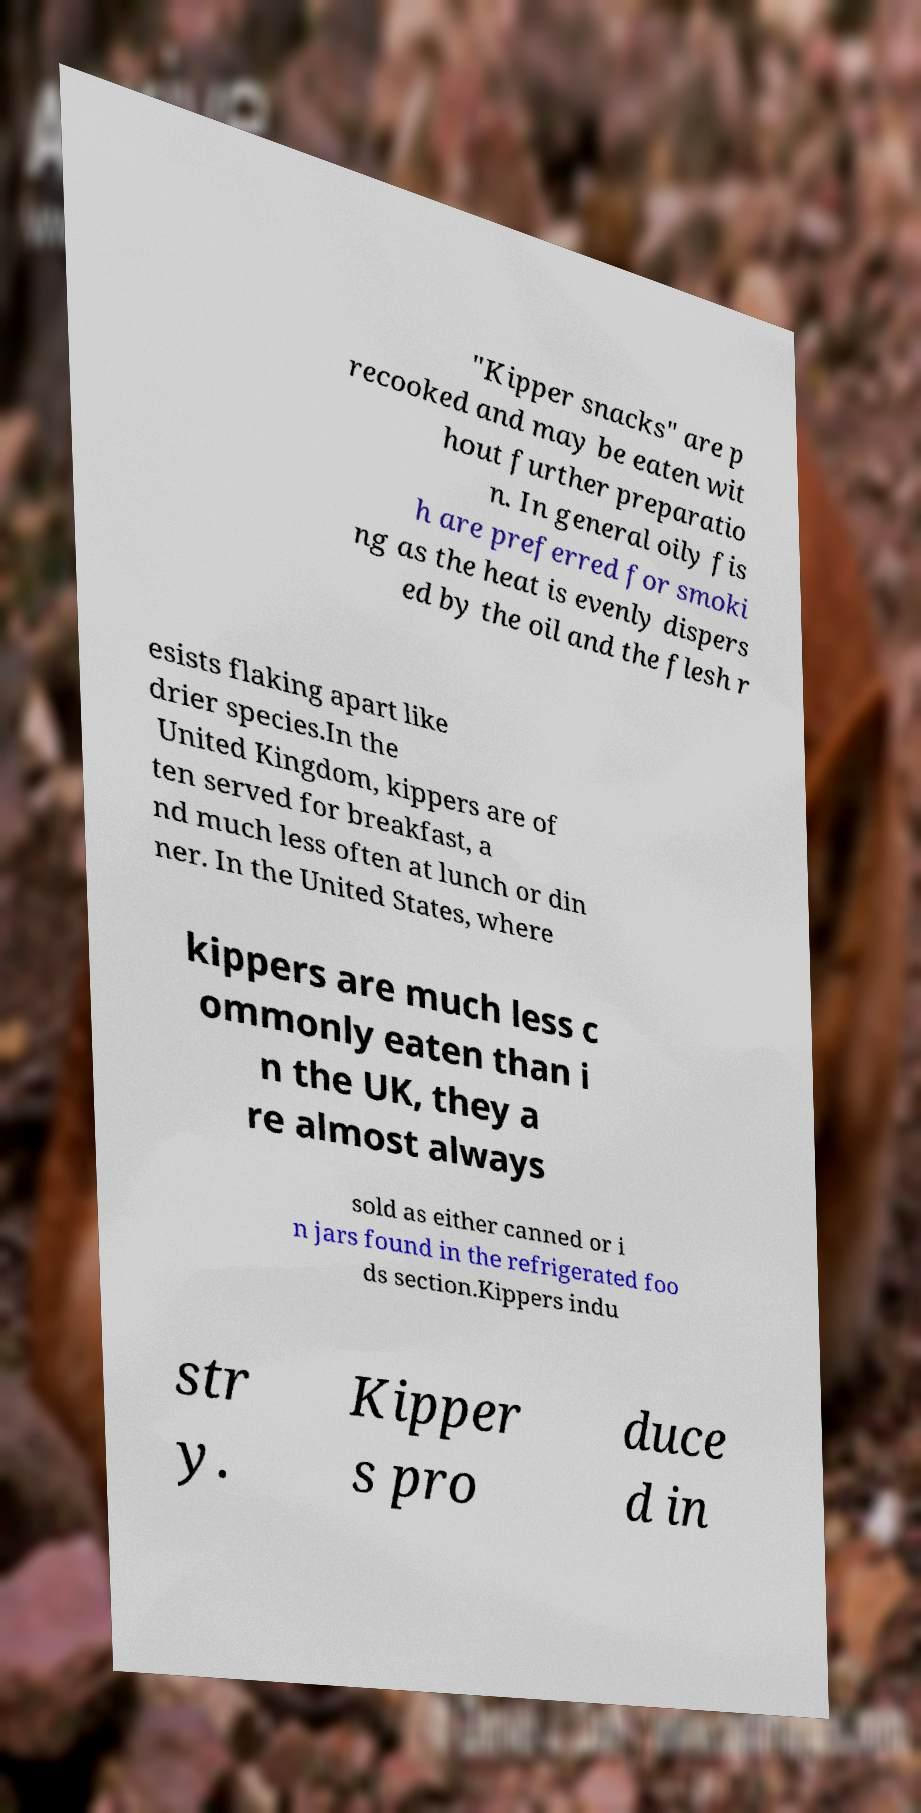Can you read and provide the text displayed in the image?This photo seems to have some interesting text. Can you extract and type it out for me? "Kipper snacks" are p recooked and may be eaten wit hout further preparatio n. In general oily fis h are preferred for smoki ng as the heat is evenly dispers ed by the oil and the flesh r esists flaking apart like drier species.In the United Kingdom, kippers are of ten served for breakfast, a nd much less often at lunch or din ner. In the United States, where kippers are much less c ommonly eaten than i n the UK, they a re almost always sold as either canned or i n jars found in the refrigerated foo ds section.Kippers indu str y. Kipper s pro duce d in 